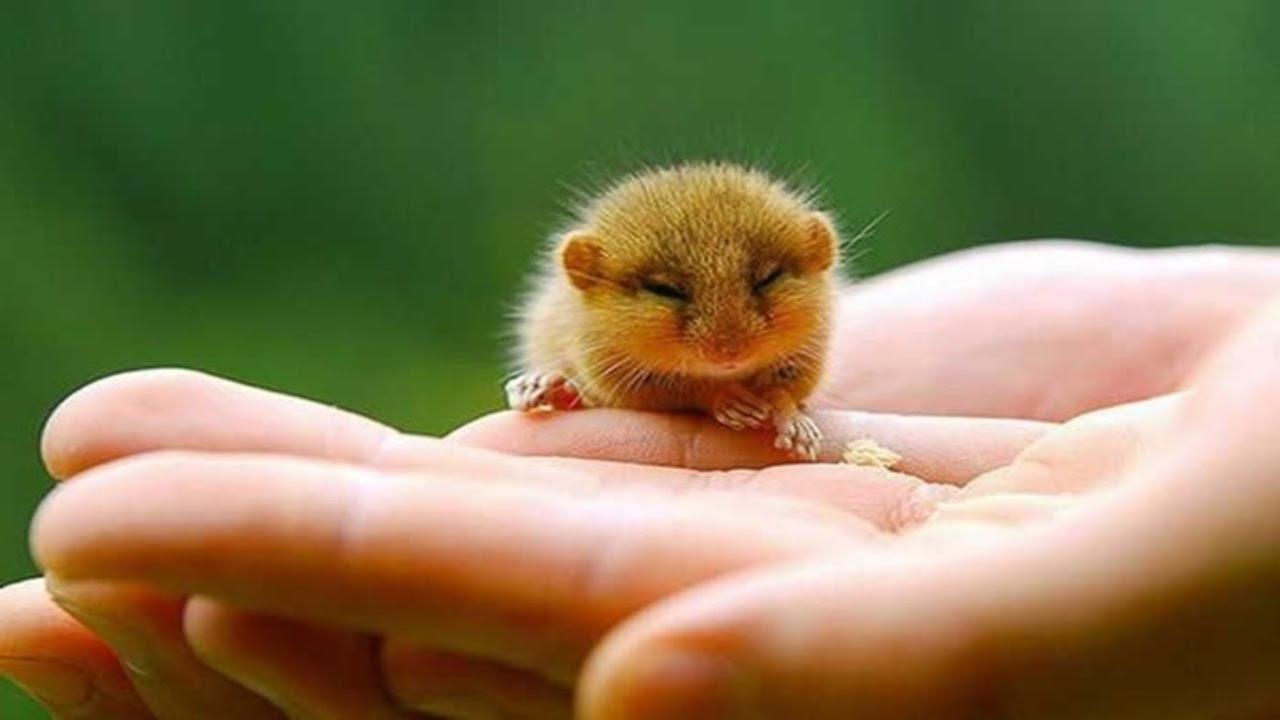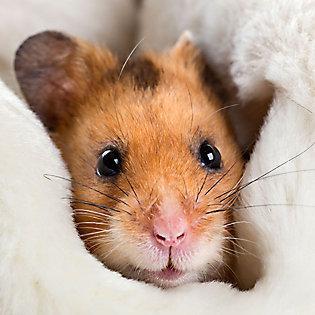The first image is the image on the left, the second image is the image on the right. Assess this claim about the two images: "An image shows exactly one pet rodent nibbling on a greenish tinged produce item.". Correct or not? Answer yes or no. No. The first image is the image on the left, the second image is the image on the right. Examine the images to the left and right. Is the description "Two rodents in one of the images are face to face." accurate? Answer yes or no. No. 